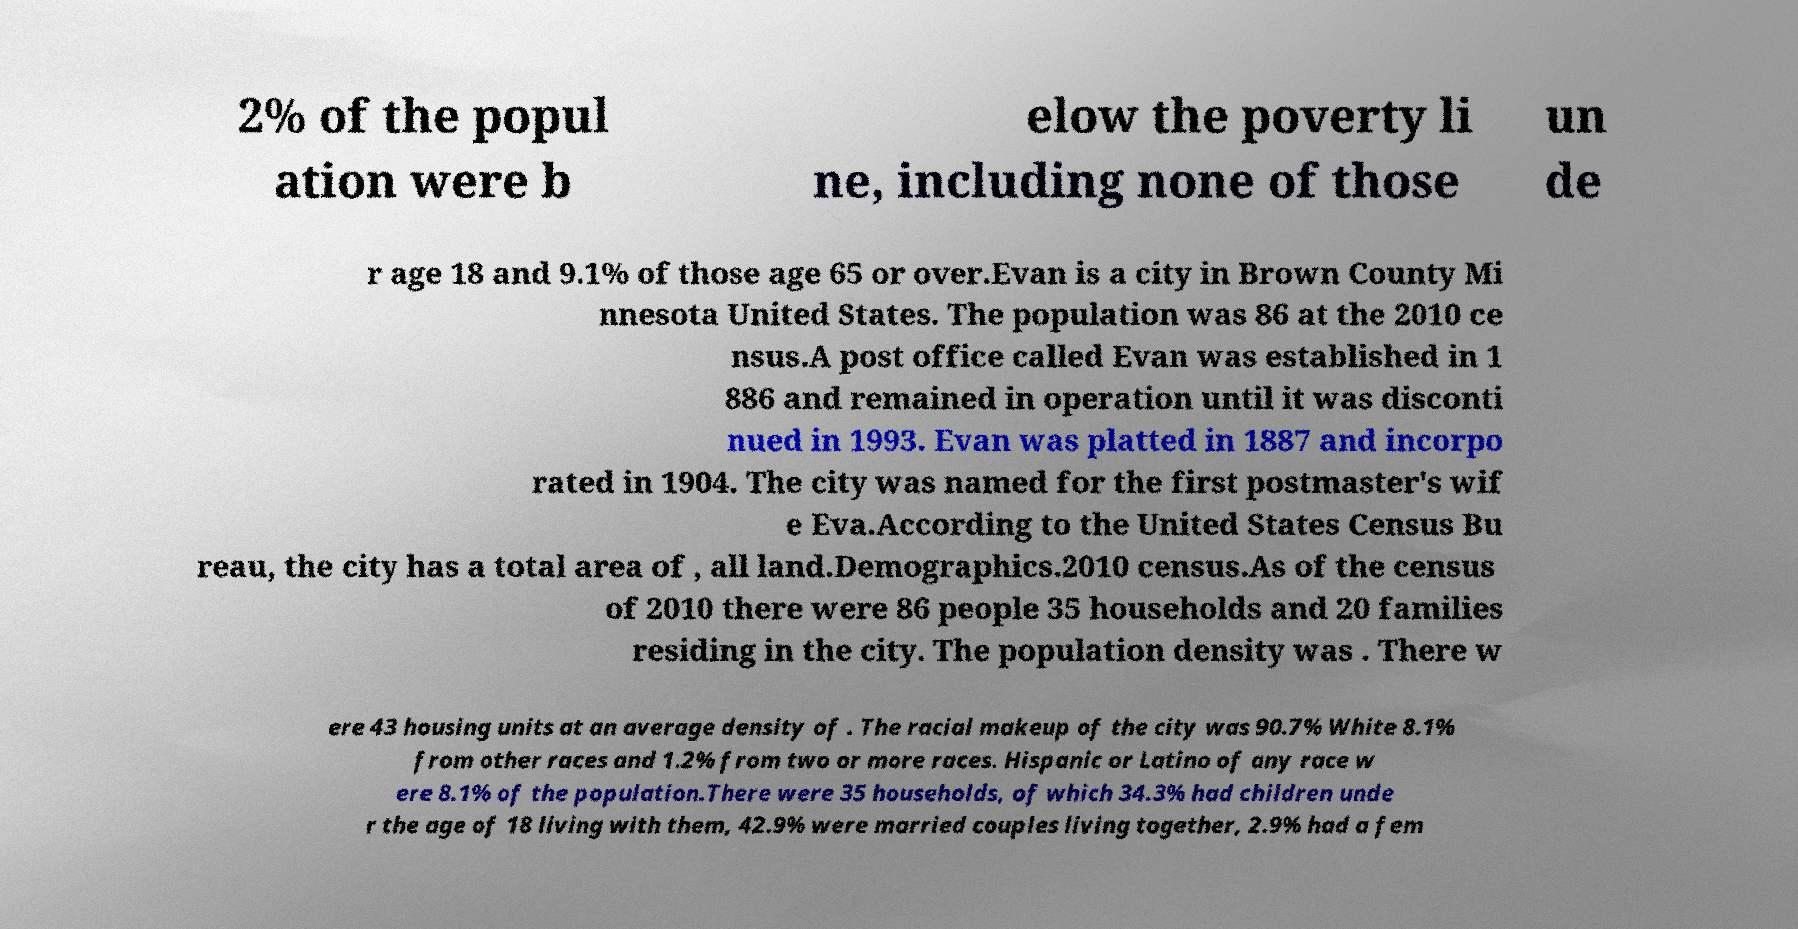For documentation purposes, I need the text within this image transcribed. Could you provide that? 2% of the popul ation were b elow the poverty li ne, including none of those un de r age 18 and 9.1% of those age 65 or over.Evan is a city in Brown County Mi nnesota United States. The population was 86 at the 2010 ce nsus.A post office called Evan was established in 1 886 and remained in operation until it was disconti nued in 1993. Evan was platted in 1887 and incorpo rated in 1904. The city was named for the first postmaster's wif e Eva.According to the United States Census Bu reau, the city has a total area of , all land.Demographics.2010 census.As of the census of 2010 there were 86 people 35 households and 20 families residing in the city. The population density was . There w ere 43 housing units at an average density of . The racial makeup of the city was 90.7% White 8.1% from other races and 1.2% from two or more races. Hispanic or Latino of any race w ere 8.1% of the population.There were 35 households, of which 34.3% had children unde r the age of 18 living with them, 42.9% were married couples living together, 2.9% had a fem 